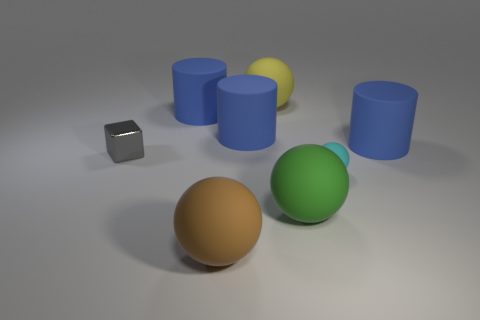Is the material of the brown ball the same as the small gray block?
Offer a very short reply. No. How many metal things are either blocks or brown cylinders?
Ensure brevity in your answer.  1. There is a big blue object right of the big matte sphere behind the tiny cyan sphere; what shape is it?
Keep it short and to the point. Cylinder. How many things are either big cylinders that are right of the yellow matte object or big matte cylinders to the right of the big yellow object?
Give a very brief answer. 1. What shape is the big yellow object that is the same material as the green ball?
Your answer should be compact. Sphere. Are there any other things of the same color as the tiny matte sphere?
Give a very brief answer. No. There is a yellow object that is the same shape as the tiny cyan object; what material is it?
Offer a terse response. Rubber. How many other things are the same size as the green sphere?
Provide a short and direct response. 5. What is the material of the large brown ball?
Your response must be concise. Rubber. Is the number of cyan rubber spheres behind the large brown matte ball greater than the number of large yellow rubber cylinders?
Your answer should be very brief. Yes. 